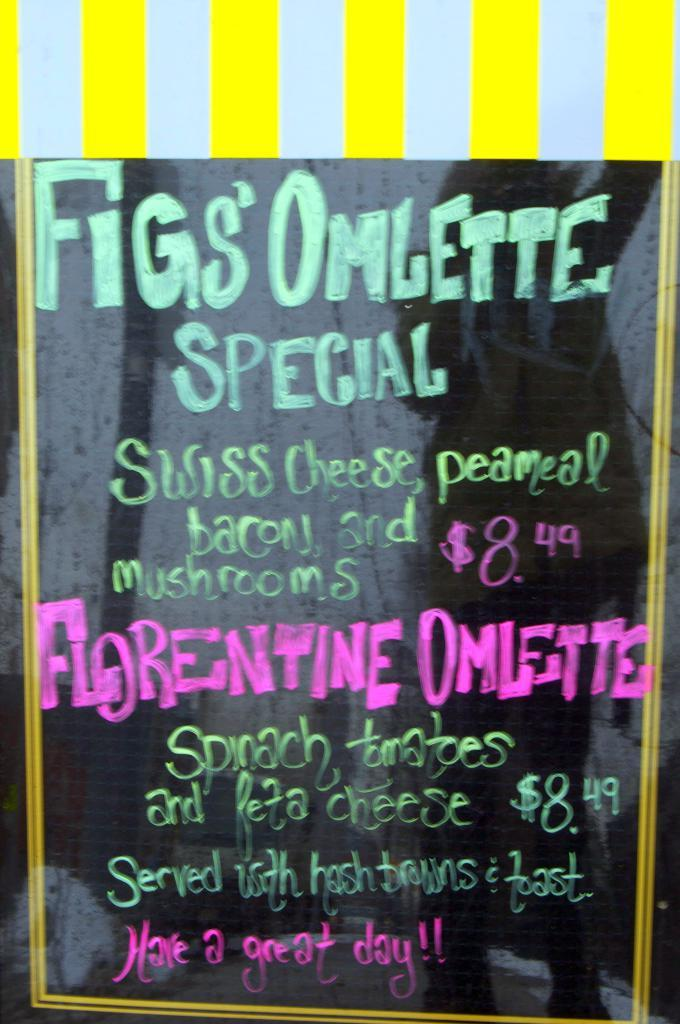<image>
Present a compact description of the photo's key features. Chalk on blackboard sign announcing Fig's Omlette Special in sea foam green 